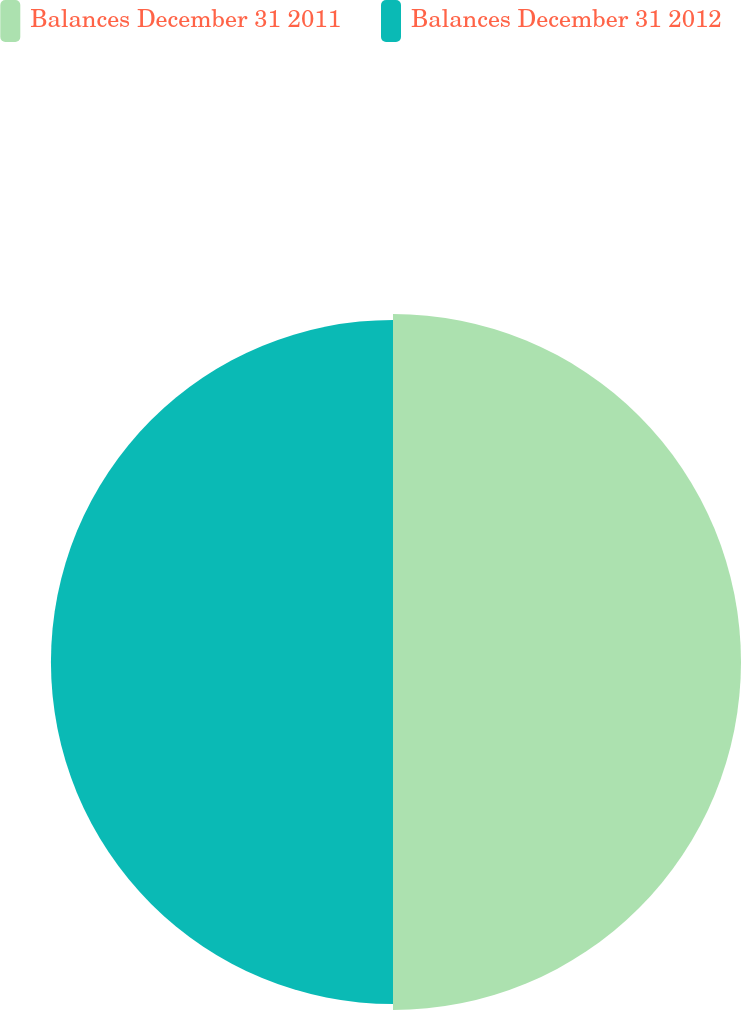<chart> <loc_0><loc_0><loc_500><loc_500><pie_chart><fcel>Balances December 31 2011<fcel>Balances December 31 2012<nl><fcel>50.43%<fcel>49.57%<nl></chart> 